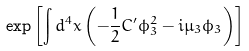<formula> <loc_0><loc_0><loc_500><loc_500>\exp \left [ \int d ^ { 4 } x \left ( - \frac { 1 } { 2 } C ^ { \prime } \phi _ { 3 } ^ { 2 } - i \mu _ { 3 } \phi _ { 3 } \right ) \right ]</formula> 